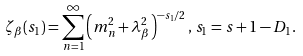Convert formula to latex. <formula><loc_0><loc_0><loc_500><loc_500>\zeta _ { \beta } ( s _ { 1 } ) = \sum _ { n = 1 } ^ { \infty } \left ( m _ { n } ^ { 2 } + \lambda _ { \beta } ^ { 2 } \right ) ^ { - s _ { 1 } / 2 } , \, s _ { 1 } = s + 1 - D _ { 1 } .</formula> 